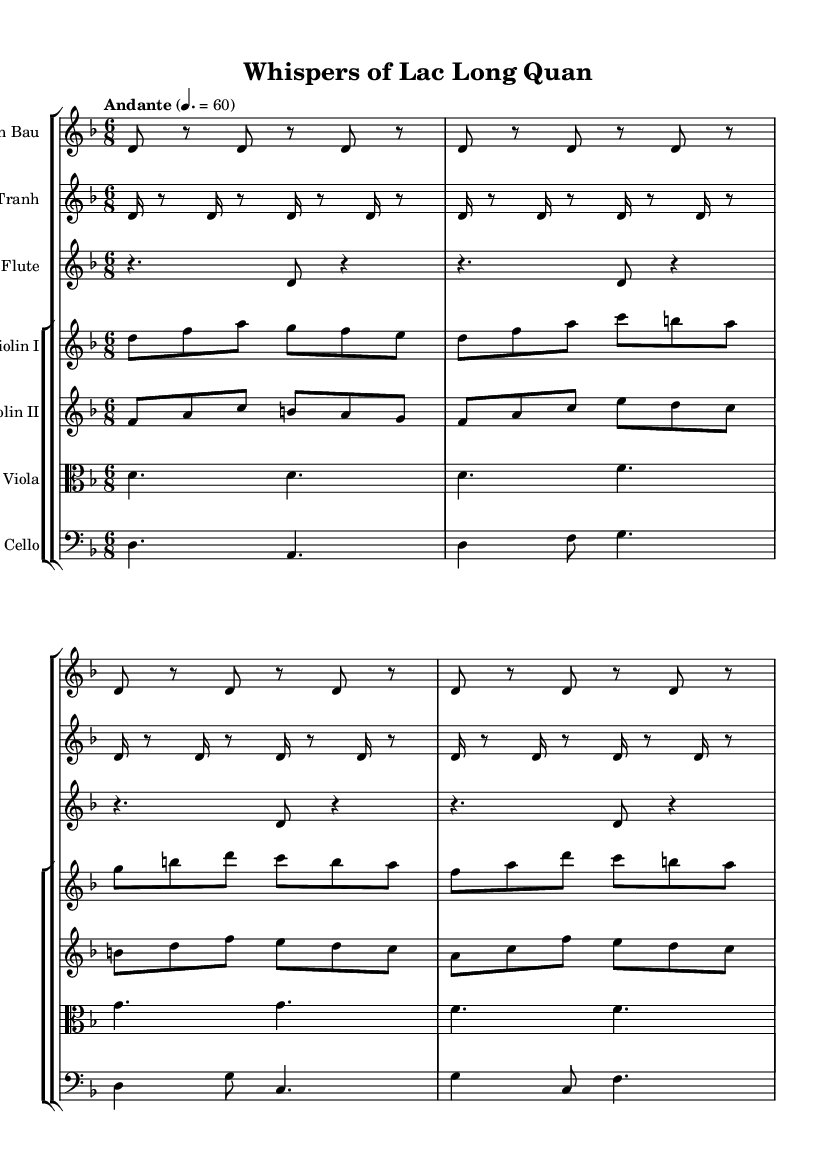What is the key signature of this music? The key signature is D minor, which has one flat (B flat). This can be determined by looking at the key signature indicated at the beginning of the sheet music.
Answer: D minor What is the time signature of this piece? The time signature is 6/8, which signifies six beats per measure with an eighth note receiving one beat. This is indicated by the notation found at the beginning of the music.
Answer: 6/8 What is the tempo marking of this soundtrack? The tempo marking indicates "Andante" with a metronome marking of 60 beats per minute. This is usually found in the header or tempo section of the sheet music.
Answer: Andante 4. = 60 How many instruments are present in this score? There are five distinct instruments listed in the score: Dan Bau, Dan Tranh, Flute, Violin I, Violin II, Viola, and Cello. Count each instrument staff to arrive at the total.
Answer: Seven Which instrument has the highest pitch in this piece? The Flute typically has the highest pitch range in this score compared to the other instruments such as violin, viola, and cello. This can be inferred by examining their respective notations.
Answer: Flute What is the rhythmic pattern of the Dan Tranh part? The rhythmic pattern for the Dan Tranh consists of alternating sixteenth notes and eighth notes, giving a flowing feel typical to the piece. This can be identified through the repeated notational structure present in that staff.
Answer: Sixteenth and eighth notes Which instruments are playing in the lowest register? The Cello plays in the lowest register as it is notated in a bass clef, which usually represents lower pitches compared to the other instruments in treble clef. This can be perceived by observing the clef used and the note pitch range in the respective staves.
Answer: Cello 